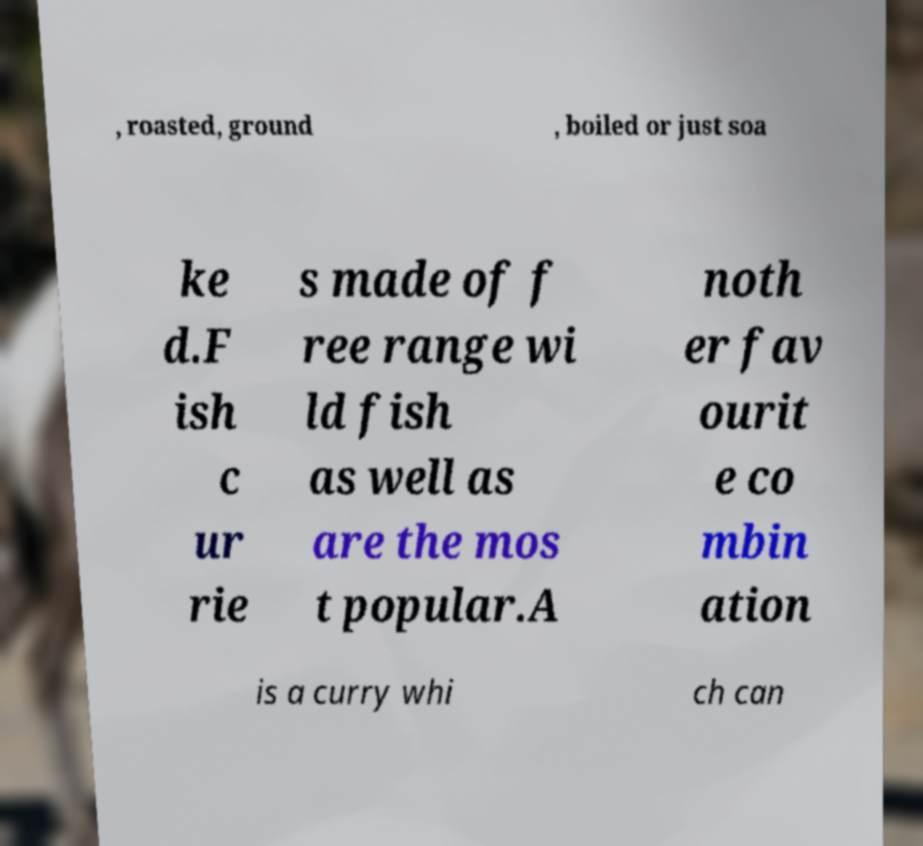Please identify and transcribe the text found in this image. , roasted, ground , boiled or just soa ke d.F ish c ur rie s made of f ree range wi ld fish as well as are the mos t popular.A noth er fav ourit e co mbin ation is a curry whi ch can 